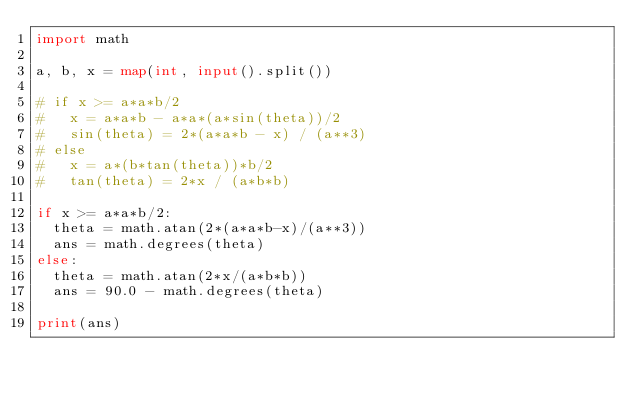<code> <loc_0><loc_0><loc_500><loc_500><_Python_>import math

a, b, x = map(int, input().split())

# if x >= a*a*b/2
#   x = a*a*b - a*a*(a*sin(theta))/2
#   sin(theta) = 2*(a*a*b - x) / (a**3)
# else
#   x = a*(b*tan(theta))*b/2
#   tan(theta) = 2*x / (a*b*b)

if x >= a*a*b/2:
  theta = math.atan(2*(a*a*b-x)/(a**3))
  ans = math.degrees(theta)
else:
  theta = math.atan(2*x/(a*b*b))
  ans = 90.0 - math.degrees(theta)

print(ans)
</code> 